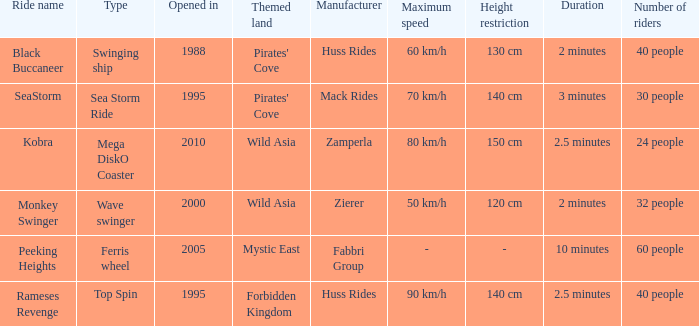What ride was manufactured by Zierer? Monkey Swinger. 